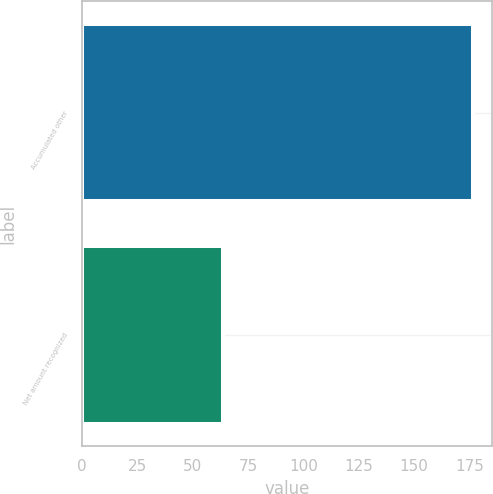<chart> <loc_0><loc_0><loc_500><loc_500><bar_chart><fcel>Accumulated other<fcel>Net amount recognized<nl><fcel>176.5<fcel>63.7<nl></chart> 